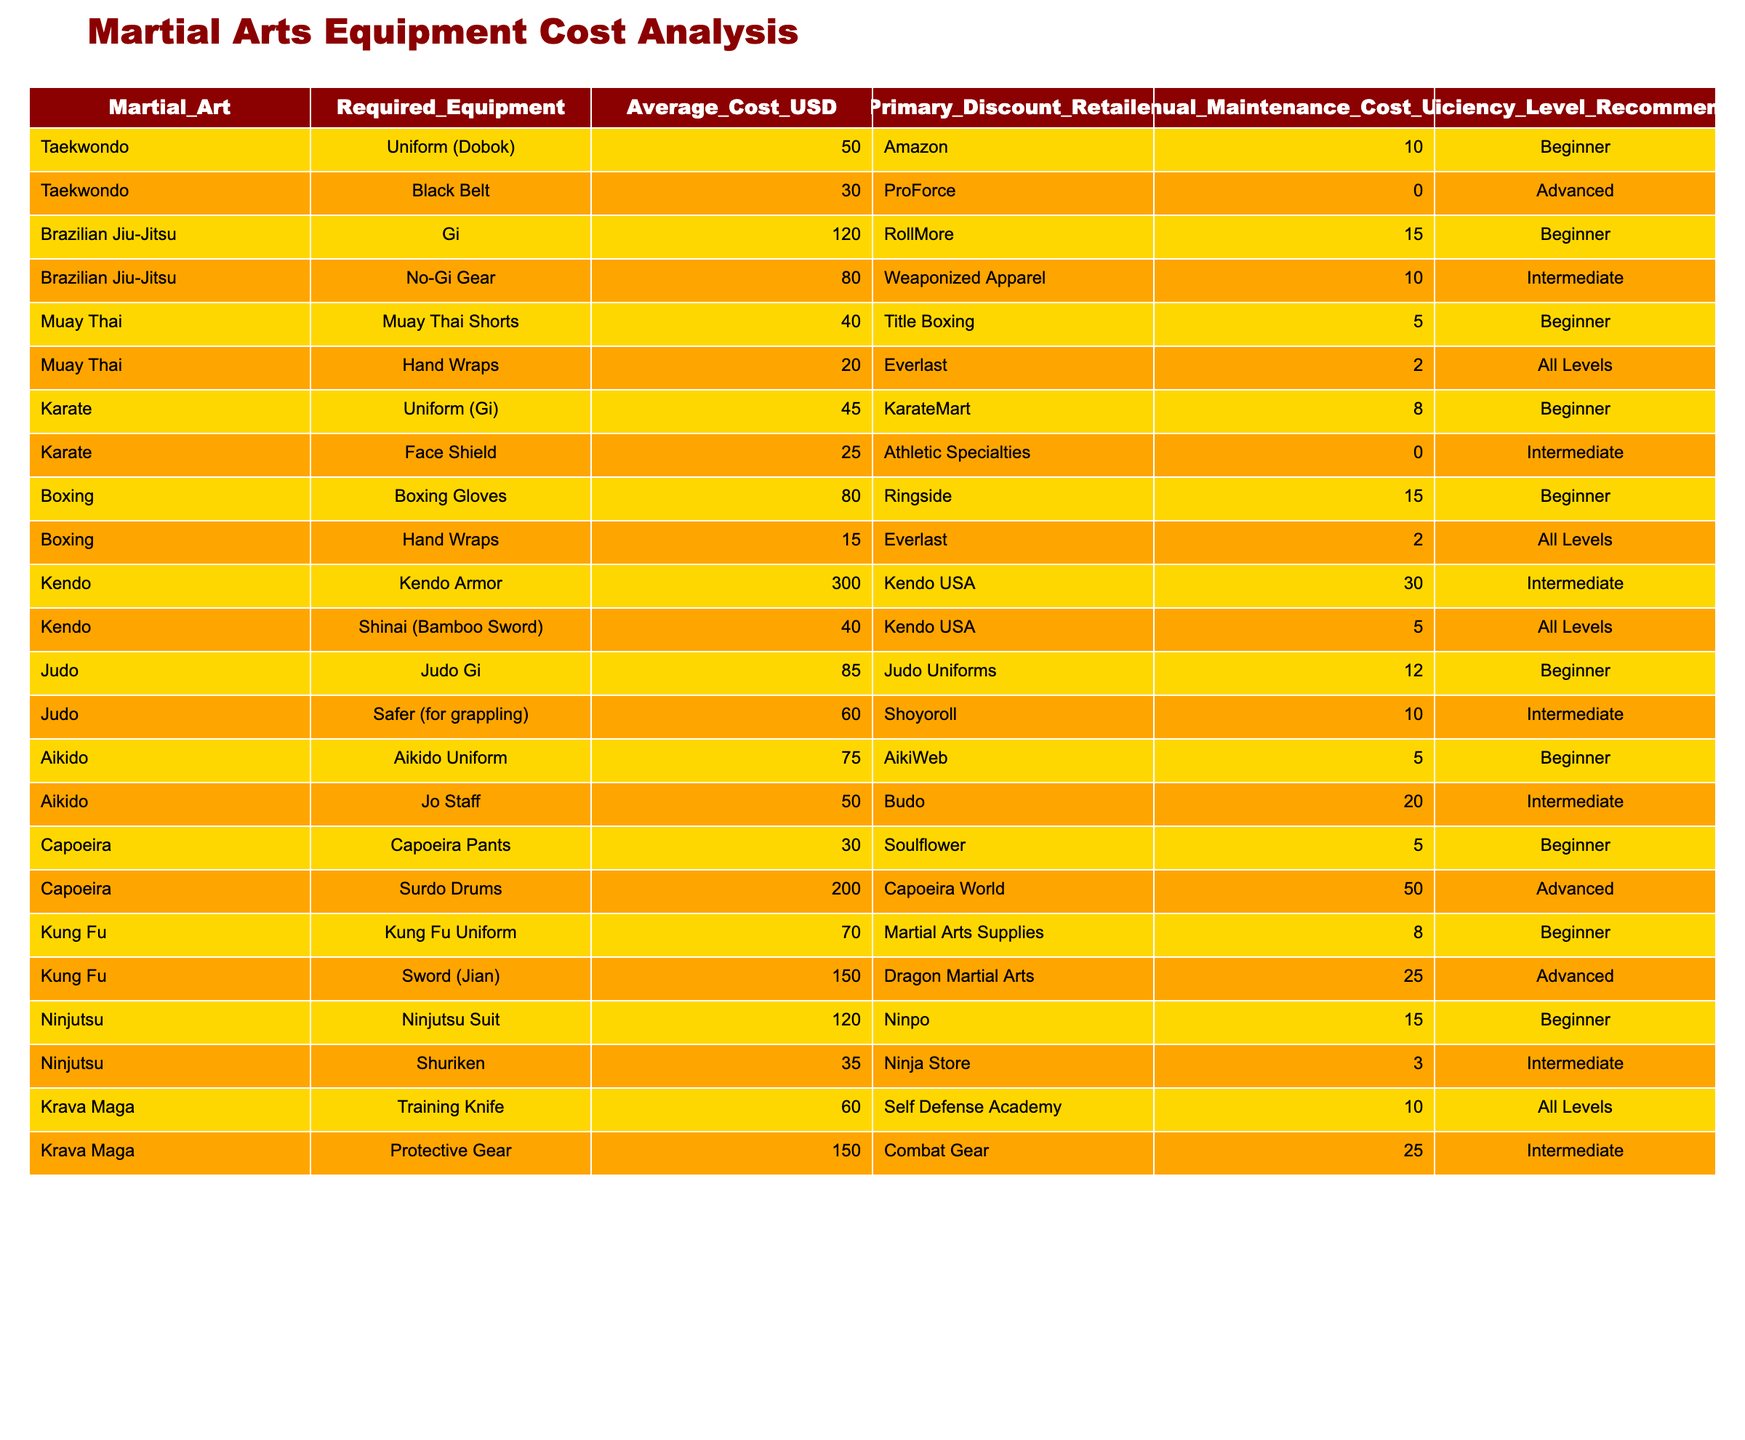What's the average cost of equipment for Taekwondo? The average cost for Taekwondo is calculated by taking the average of the costs of the required equipment: 50 (Uniform) + 30 (Black Belt) = 80, then dividing by the number of items (2), so 80/2 = 40.
Answer: 40 What is the total maintenance cost for Brazilian Jiu-Jitsu equipment? For Brazilian Jiu-Jitsu, the maintenance costs are 15 (Gi) + 10 (No-Gi Gear) = 25, so the total maintenance cost is 25.
Answer: 25 Is the average cost of equipment for Muay Thai higher than that for Capoeira? The average cost for Muay Thai is (40 + 20) / 2 = 30, while for Capoeira, it is (30 + 200) / 2 = 115. Since 30 is not greater than 115, the answer is false.
Answer: No What equipment has the highest average cost? To determine this, we look at the average costs listed: Kendo Armor = 300, Capoeira Drums = 200, and others. Kendo Armor is the highest of all.
Answer: Kendo Armor What is the total annual maintenance cost for all martial arts disciplines combined? We need to find the maintenance costs for each discipline: Taekwondo 10 + 0 + Brazilian Jiu-Jitsu 15 + 10 + Muay Thai 5 + 2 + Karate 8 + 0 + Boxing 15 + 2 + Kendo 30 + 5 + Judo 12 + 10 + Aikido 5 + 20 + Capoeira 5 + 50 + Kung Fu 8 + 0 + Ninjutsu 15 + 3 + Krava Maga 10 + 25 = 370.
Answer: 370 Is the average cost of equipment for Kung Fu greater than that of Judo? For Kung Fu, the average is (70 + 150) / 2 = 110, and for Judo, it is (85 + 60) / 2 = 72. Since 110 is greater than 72, the answer is yes.
Answer: Yes 